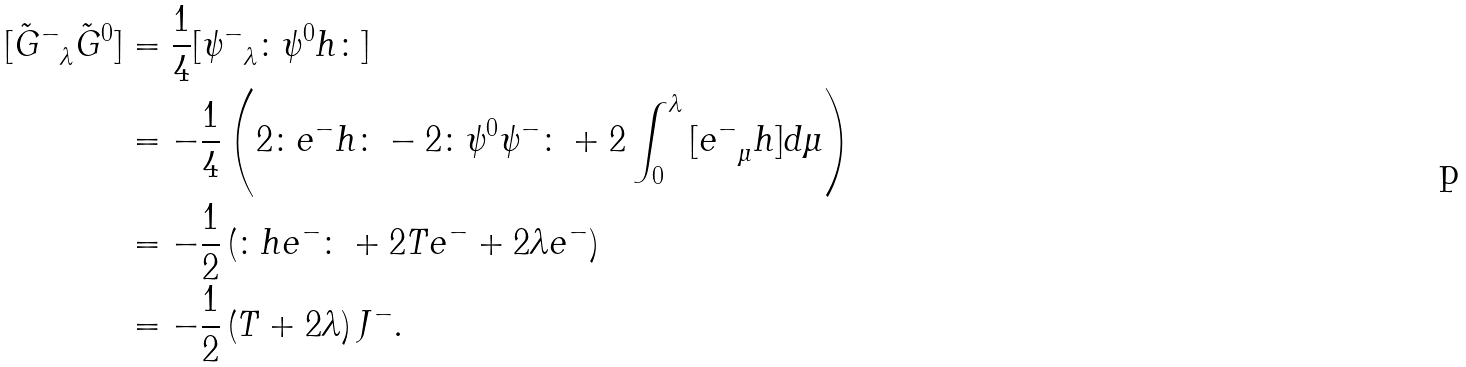Convert formula to latex. <formula><loc_0><loc_0><loc_500><loc_500>{ [ \tilde { G } ^ { - } } _ { \lambda } \tilde { G } ^ { 0 } ] & = \frac { 1 } { 4 } { [ \psi ^ { - } } _ { \lambda } \colon \psi ^ { 0 } h \colon ] \\ & = - \frac { 1 } { 4 } \left ( 2 \colon e ^ { - } h \colon - 2 \colon \psi ^ { 0 } \psi ^ { - } \colon + 2 \int _ { 0 } ^ { \lambda } { [ e ^ { - } } _ { \mu } h ] d \mu \right ) \\ & = - \frac { 1 } { 2 } \left ( \colon h e ^ { - } \colon + 2 T e ^ { - } + 2 \lambda e ^ { - } \right ) \\ & = - \frac { 1 } { 2 } \left ( T + 2 \lambda \right ) J ^ { - } .</formula> 